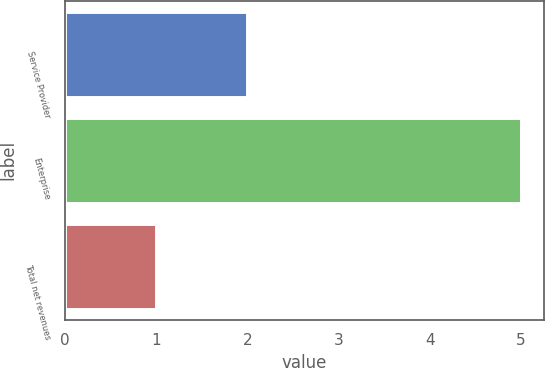Convert chart. <chart><loc_0><loc_0><loc_500><loc_500><bar_chart><fcel>Service Provider<fcel>Enterprise<fcel>Total net revenues<nl><fcel>2<fcel>5<fcel>1<nl></chart> 